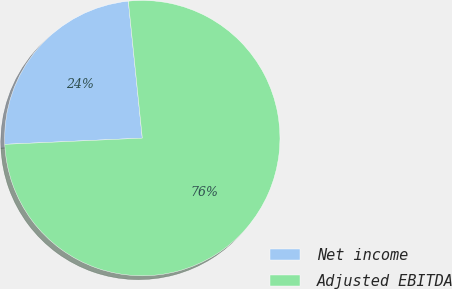Convert chart. <chart><loc_0><loc_0><loc_500><loc_500><pie_chart><fcel>Net income<fcel>Adjusted EBITDA<nl><fcel>24.1%<fcel>75.9%<nl></chart> 